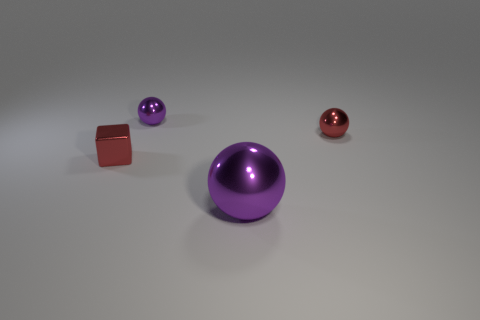Add 1 red cubes. How many objects exist? 5 Subtract all cubes. How many objects are left? 3 Add 4 tiny red objects. How many tiny red objects are left? 6 Add 3 metallic cylinders. How many metallic cylinders exist? 3 Subtract 0 brown spheres. How many objects are left? 4 Subtract all small gray metal spheres. Subtract all tiny red shiny spheres. How many objects are left? 3 